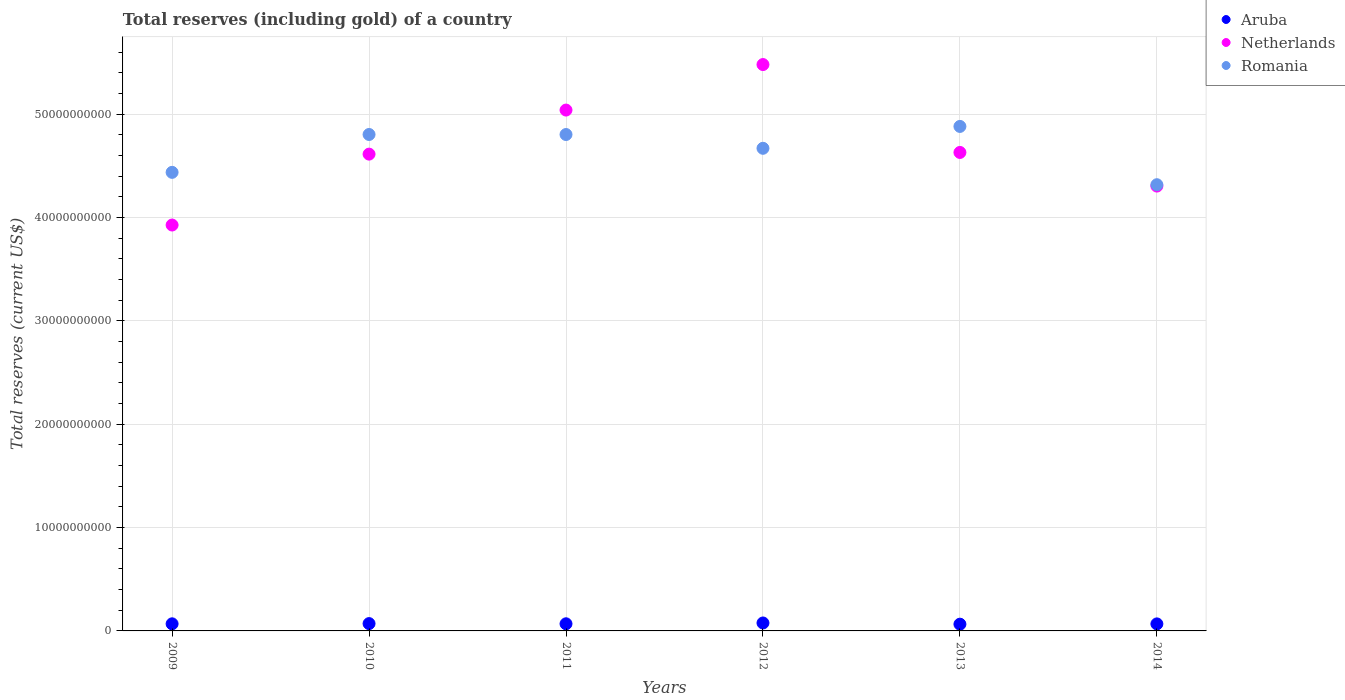How many different coloured dotlines are there?
Offer a terse response. 3. Is the number of dotlines equal to the number of legend labels?
Offer a terse response. Yes. What is the total reserves (including gold) in Aruba in 2013?
Make the answer very short. 6.53e+08. Across all years, what is the maximum total reserves (including gold) in Romania?
Give a very brief answer. 4.88e+1. Across all years, what is the minimum total reserves (including gold) in Netherlands?
Provide a succinct answer. 3.93e+1. What is the total total reserves (including gold) in Aruba in the graph?
Make the answer very short. 4.19e+09. What is the difference between the total reserves (including gold) in Netherlands in 2009 and that in 2013?
Offer a very short reply. -7.02e+09. What is the difference between the total reserves (including gold) in Romania in 2013 and the total reserves (including gold) in Netherlands in 2009?
Ensure brevity in your answer.  9.54e+09. What is the average total reserves (including gold) in Netherlands per year?
Keep it short and to the point. 4.67e+1. In the year 2011, what is the difference between the total reserves (including gold) in Romania and total reserves (including gold) in Netherlands?
Provide a short and direct response. -2.37e+09. What is the ratio of the total reserves (including gold) in Netherlands in 2010 to that in 2013?
Ensure brevity in your answer.  1. Is the difference between the total reserves (including gold) in Romania in 2011 and 2014 greater than the difference between the total reserves (including gold) in Netherlands in 2011 and 2014?
Provide a succinct answer. No. What is the difference between the highest and the second highest total reserves (including gold) in Romania?
Make the answer very short. 7.80e+08. What is the difference between the highest and the lowest total reserves (including gold) in Romania?
Offer a terse response. 5.64e+09. In how many years, is the total reserves (including gold) in Romania greater than the average total reserves (including gold) in Romania taken over all years?
Offer a terse response. 4. How many years are there in the graph?
Your answer should be compact. 6. Are the values on the major ticks of Y-axis written in scientific E-notation?
Your response must be concise. No. How are the legend labels stacked?
Give a very brief answer. Vertical. What is the title of the graph?
Keep it short and to the point. Total reserves (including gold) of a country. What is the label or title of the X-axis?
Ensure brevity in your answer.  Years. What is the label or title of the Y-axis?
Your response must be concise. Total reserves (current US$). What is the Total reserves (current US$) in Aruba in 2009?
Provide a short and direct response. 6.87e+08. What is the Total reserves (current US$) in Netherlands in 2009?
Provide a succinct answer. 3.93e+1. What is the Total reserves (current US$) of Romania in 2009?
Provide a short and direct response. 4.44e+1. What is the Total reserves (current US$) of Aruba in 2010?
Your response must be concise. 7.09e+08. What is the Total reserves (current US$) of Netherlands in 2010?
Provide a short and direct response. 4.61e+1. What is the Total reserves (current US$) of Romania in 2010?
Provide a short and direct response. 4.80e+1. What is the Total reserves (current US$) in Aruba in 2011?
Keep it short and to the point. 6.90e+08. What is the Total reserves (current US$) in Netherlands in 2011?
Offer a very short reply. 5.04e+1. What is the Total reserves (current US$) in Romania in 2011?
Your answer should be compact. 4.80e+1. What is the Total reserves (current US$) in Aruba in 2012?
Provide a succinct answer. 7.69e+08. What is the Total reserves (current US$) in Netherlands in 2012?
Offer a terse response. 5.48e+1. What is the Total reserves (current US$) in Romania in 2012?
Offer a terse response. 4.67e+1. What is the Total reserves (current US$) in Aruba in 2013?
Ensure brevity in your answer.  6.53e+08. What is the Total reserves (current US$) of Netherlands in 2013?
Give a very brief answer. 4.63e+1. What is the Total reserves (current US$) in Romania in 2013?
Your answer should be compact. 4.88e+1. What is the Total reserves (current US$) of Aruba in 2014?
Ensure brevity in your answer.  6.80e+08. What is the Total reserves (current US$) of Netherlands in 2014?
Offer a very short reply. 4.31e+1. What is the Total reserves (current US$) of Romania in 2014?
Provide a succinct answer. 4.32e+1. Across all years, what is the maximum Total reserves (current US$) in Aruba?
Your answer should be very brief. 7.69e+08. Across all years, what is the maximum Total reserves (current US$) in Netherlands?
Your answer should be compact. 5.48e+1. Across all years, what is the maximum Total reserves (current US$) of Romania?
Give a very brief answer. 4.88e+1. Across all years, what is the minimum Total reserves (current US$) in Aruba?
Provide a short and direct response. 6.53e+08. Across all years, what is the minimum Total reserves (current US$) in Netherlands?
Keep it short and to the point. 3.93e+1. Across all years, what is the minimum Total reserves (current US$) in Romania?
Offer a very short reply. 4.32e+1. What is the total Total reserves (current US$) in Aruba in the graph?
Provide a succinct answer. 4.19e+09. What is the total Total reserves (current US$) of Netherlands in the graph?
Provide a succinct answer. 2.80e+11. What is the total Total reserves (current US$) in Romania in the graph?
Make the answer very short. 2.79e+11. What is the difference between the Total reserves (current US$) of Aruba in 2009 and that in 2010?
Provide a succinct answer. -2.17e+07. What is the difference between the Total reserves (current US$) of Netherlands in 2009 and that in 2010?
Your response must be concise. -6.86e+09. What is the difference between the Total reserves (current US$) in Romania in 2009 and that in 2010?
Keep it short and to the point. -3.66e+09. What is the difference between the Total reserves (current US$) in Aruba in 2009 and that in 2011?
Ensure brevity in your answer.  -2.81e+06. What is the difference between the Total reserves (current US$) in Netherlands in 2009 and that in 2011?
Provide a succinct answer. -1.11e+1. What is the difference between the Total reserves (current US$) of Romania in 2009 and that in 2011?
Make the answer very short. -3.66e+09. What is the difference between the Total reserves (current US$) of Aruba in 2009 and that in 2012?
Keep it short and to the point. -8.17e+07. What is the difference between the Total reserves (current US$) of Netherlands in 2009 and that in 2012?
Offer a very short reply. -1.55e+1. What is the difference between the Total reserves (current US$) in Romania in 2009 and that in 2012?
Offer a very short reply. -2.33e+09. What is the difference between the Total reserves (current US$) in Aruba in 2009 and that in 2013?
Provide a succinct answer. 3.38e+07. What is the difference between the Total reserves (current US$) of Netherlands in 2009 and that in 2013?
Your answer should be compact. -7.02e+09. What is the difference between the Total reserves (current US$) in Romania in 2009 and that in 2013?
Your response must be concise. -4.44e+09. What is the difference between the Total reserves (current US$) in Aruba in 2009 and that in 2014?
Make the answer very short. 6.62e+06. What is the difference between the Total reserves (current US$) of Netherlands in 2009 and that in 2014?
Your answer should be compact. -3.77e+09. What is the difference between the Total reserves (current US$) in Romania in 2009 and that in 2014?
Offer a terse response. 1.20e+09. What is the difference between the Total reserves (current US$) in Aruba in 2010 and that in 2011?
Offer a very short reply. 1.89e+07. What is the difference between the Total reserves (current US$) of Netherlands in 2010 and that in 2011?
Keep it short and to the point. -4.26e+09. What is the difference between the Total reserves (current US$) in Romania in 2010 and that in 2011?
Your answer should be very brief. 3.46e+06. What is the difference between the Total reserves (current US$) in Aruba in 2010 and that in 2012?
Ensure brevity in your answer.  -5.99e+07. What is the difference between the Total reserves (current US$) of Netherlands in 2010 and that in 2012?
Provide a short and direct response. -8.67e+09. What is the difference between the Total reserves (current US$) in Romania in 2010 and that in 2012?
Give a very brief answer. 1.34e+09. What is the difference between the Total reserves (current US$) in Aruba in 2010 and that in 2013?
Your answer should be compact. 5.55e+07. What is the difference between the Total reserves (current US$) of Netherlands in 2010 and that in 2013?
Give a very brief answer. -1.62e+08. What is the difference between the Total reserves (current US$) of Romania in 2010 and that in 2013?
Offer a terse response. -7.80e+08. What is the difference between the Total reserves (current US$) of Aruba in 2010 and that in 2014?
Provide a short and direct response. 2.84e+07. What is the difference between the Total reserves (current US$) of Netherlands in 2010 and that in 2014?
Your answer should be very brief. 3.09e+09. What is the difference between the Total reserves (current US$) of Romania in 2010 and that in 2014?
Your answer should be compact. 4.86e+09. What is the difference between the Total reserves (current US$) in Aruba in 2011 and that in 2012?
Provide a short and direct response. -7.88e+07. What is the difference between the Total reserves (current US$) of Netherlands in 2011 and that in 2012?
Keep it short and to the point. -4.41e+09. What is the difference between the Total reserves (current US$) of Romania in 2011 and that in 2012?
Provide a succinct answer. 1.33e+09. What is the difference between the Total reserves (current US$) in Aruba in 2011 and that in 2013?
Provide a short and direct response. 3.66e+07. What is the difference between the Total reserves (current US$) in Netherlands in 2011 and that in 2013?
Offer a very short reply. 4.10e+09. What is the difference between the Total reserves (current US$) of Romania in 2011 and that in 2013?
Offer a terse response. -7.83e+08. What is the difference between the Total reserves (current US$) in Aruba in 2011 and that in 2014?
Your response must be concise. 9.42e+06. What is the difference between the Total reserves (current US$) of Netherlands in 2011 and that in 2014?
Your response must be concise. 7.36e+09. What is the difference between the Total reserves (current US$) of Romania in 2011 and that in 2014?
Provide a succinct answer. 4.86e+09. What is the difference between the Total reserves (current US$) in Aruba in 2012 and that in 2013?
Your response must be concise. 1.15e+08. What is the difference between the Total reserves (current US$) of Netherlands in 2012 and that in 2013?
Keep it short and to the point. 8.51e+09. What is the difference between the Total reserves (current US$) of Romania in 2012 and that in 2013?
Make the answer very short. -2.12e+09. What is the difference between the Total reserves (current US$) of Aruba in 2012 and that in 2014?
Ensure brevity in your answer.  8.83e+07. What is the difference between the Total reserves (current US$) of Netherlands in 2012 and that in 2014?
Your answer should be very brief. 1.18e+1. What is the difference between the Total reserves (current US$) in Romania in 2012 and that in 2014?
Your answer should be compact. 3.52e+09. What is the difference between the Total reserves (current US$) of Aruba in 2013 and that in 2014?
Offer a terse response. -2.72e+07. What is the difference between the Total reserves (current US$) of Netherlands in 2013 and that in 2014?
Offer a terse response. 3.25e+09. What is the difference between the Total reserves (current US$) of Romania in 2013 and that in 2014?
Your answer should be compact. 5.64e+09. What is the difference between the Total reserves (current US$) in Aruba in 2009 and the Total reserves (current US$) in Netherlands in 2010?
Your response must be concise. -4.55e+1. What is the difference between the Total reserves (current US$) of Aruba in 2009 and the Total reserves (current US$) of Romania in 2010?
Your answer should be very brief. -4.74e+1. What is the difference between the Total reserves (current US$) of Netherlands in 2009 and the Total reserves (current US$) of Romania in 2010?
Your response must be concise. -8.76e+09. What is the difference between the Total reserves (current US$) of Aruba in 2009 and the Total reserves (current US$) of Netherlands in 2011?
Offer a terse response. -4.97e+1. What is the difference between the Total reserves (current US$) of Aruba in 2009 and the Total reserves (current US$) of Romania in 2011?
Your answer should be compact. -4.74e+1. What is the difference between the Total reserves (current US$) in Netherlands in 2009 and the Total reserves (current US$) in Romania in 2011?
Your answer should be very brief. -8.76e+09. What is the difference between the Total reserves (current US$) of Aruba in 2009 and the Total reserves (current US$) of Netherlands in 2012?
Provide a short and direct response. -5.41e+1. What is the difference between the Total reserves (current US$) of Aruba in 2009 and the Total reserves (current US$) of Romania in 2012?
Provide a short and direct response. -4.60e+1. What is the difference between the Total reserves (current US$) of Netherlands in 2009 and the Total reserves (current US$) of Romania in 2012?
Make the answer very short. -7.43e+09. What is the difference between the Total reserves (current US$) in Aruba in 2009 and the Total reserves (current US$) in Netherlands in 2013?
Provide a short and direct response. -4.56e+1. What is the difference between the Total reserves (current US$) of Aruba in 2009 and the Total reserves (current US$) of Romania in 2013?
Offer a terse response. -4.81e+1. What is the difference between the Total reserves (current US$) in Netherlands in 2009 and the Total reserves (current US$) in Romania in 2013?
Give a very brief answer. -9.54e+09. What is the difference between the Total reserves (current US$) in Aruba in 2009 and the Total reserves (current US$) in Netherlands in 2014?
Give a very brief answer. -4.24e+1. What is the difference between the Total reserves (current US$) of Aruba in 2009 and the Total reserves (current US$) of Romania in 2014?
Ensure brevity in your answer.  -4.25e+1. What is the difference between the Total reserves (current US$) of Netherlands in 2009 and the Total reserves (current US$) of Romania in 2014?
Provide a short and direct response. -3.90e+09. What is the difference between the Total reserves (current US$) of Aruba in 2010 and the Total reserves (current US$) of Netherlands in 2011?
Provide a short and direct response. -4.97e+1. What is the difference between the Total reserves (current US$) of Aruba in 2010 and the Total reserves (current US$) of Romania in 2011?
Provide a succinct answer. -4.73e+1. What is the difference between the Total reserves (current US$) of Netherlands in 2010 and the Total reserves (current US$) of Romania in 2011?
Offer a very short reply. -1.90e+09. What is the difference between the Total reserves (current US$) of Aruba in 2010 and the Total reserves (current US$) of Netherlands in 2012?
Provide a succinct answer. -5.41e+1. What is the difference between the Total reserves (current US$) in Aruba in 2010 and the Total reserves (current US$) in Romania in 2012?
Offer a terse response. -4.60e+1. What is the difference between the Total reserves (current US$) in Netherlands in 2010 and the Total reserves (current US$) in Romania in 2012?
Provide a succinct answer. -5.64e+08. What is the difference between the Total reserves (current US$) in Aruba in 2010 and the Total reserves (current US$) in Netherlands in 2013?
Your answer should be very brief. -4.56e+1. What is the difference between the Total reserves (current US$) of Aruba in 2010 and the Total reserves (current US$) of Romania in 2013?
Provide a short and direct response. -4.81e+1. What is the difference between the Total reserves (current US$) of Netherlands in 2010 and the Total reserves (current US$) of Romania in 2013?
Your answer should be very brief. -2.68e+09. What is the difference between the Total reserves (current US$) in Aruba in 2010 and the Total reserves (current US$) in Netherlands in 2014?
Your answer should be very brief. -4.23e+1. What is the difference between the Total reserves (current US$) of Aruba in 2010 and the Total reserves (current US$) of Romania in 2014?
Your answer should be compact. -4.25e+1. What is the difference between the Total reserves (current US$) of Netherlands in 2010 and the Total reserves (current US$) of Romania in 2014?
Give a very brief answer. 2.96e+09. What is the difference between the Total reserves (current US$) of Aruba in 2011 and the Total reserves (current US$) of Netherlands in 2012?
Provide a short and direct response. -5.41e+1. What is the difference between the Total reserves (current US$) in Aruba in 2011 and the Total reserves (current US$) in Romania in 2012?
Your answer should be very brief. -4.60e+1. What is the difference between the Total reserves (current US$) in Netherlands in 2011 and the Total reserves (current US$) in Romania in 2012?
Provide a succinct answer. 3.70e+09. What is the difference between the Total reserves (current US$) in Aruba in 2011 and the Total reserves (current US$) in Netherlands in 2013?
Your answer should be compact. -4.56e+1. What is the difference between the Total reserves (current US$) in Aruba in 2011 and the Total reserves (current US$) in Romania in 2013?
Your response must be concise. -4.81e+1. What is the difference between the Total reserves (current US$) of Netherlands in 2011 and the Total reserves (current US$) of Romania in 2013?
Offer a terse response. 1.58e+09. What is the difference between the Total reserves (current US$) of Aruba in 2011 and the Total reserves (current US$) of Netherlands in 2014?
Make the answer very short. -4.24e+1. What is the difference between the Total reserves (current US$) of Aruba in 2011 and the Total reserves (current US$) of Romania in 2014?
Make the answer very short. -4.25e+1. What is the difference between the Total reserves (current US$) of Netherlands in 2011 and the Total reserves (current US$) of Romania in 2014?
Your response must be concise. 7.22e+09. What is the difference between the Total reserves (current US$) of Aruba in 2012 and the Total reserves (current US$) of Netherlands in 2013?
Keep it short and to the point. -4.55e+1. What is the difference between the Total reserves (current US$) of Aruba in 2012 and the Total reserves (current US$) of Romania in 2013?
Keep it short and to the point. -4.81e+1. What is the difference between the Total reserves (current US$) in Netherlands in 2012 and the Total reserves (current US$) in Romania in 2013?
Offer a very short reply. 5.99e+09. What is the difference between the Total reserves (current US$) of Aruba in 2012 and the Total reserves (current US$) of Netherlands in 2014?
Provide a short and direct response. -4.23e+1. What is the difference between the Total reserves (current US$) in Aruba in 2012 and the Total reserves (current US$) in Romania in 2014?
Your response must be concise. -4.24e+1. What is the difference between the Total reserves (current US$) of Netherlands in 2012 and the Total reserves (current US$) of Romania in 2014?
Provide a succinct answer. 1.16e+1. What is the difference between the Total reserves (current US$) in Aruba in 2013 and the Total reserves (current US$) in Netherlands in 2014?
Keep it short and to the point. -4.24e+1. What is the difference between the Total reserves (current US$) in Aruba in 2013 and the Total reserves (current US$) in Romania in 2014?
Your response must be concise. -4.25e+1. What is the difference between the Total reserves (current US$) of Netherlands in 2013 and the Total reserves (current US$) of Romania in 2014?
Provide a succinct answer. 3.12e+09. What is the average Total reserves (current US$) in Aruba per year?
Keep it short and to the point. 6.98e+08. What is the average Total reserves (current US$) in Netherlands per year?
Ensure brevity in your answer.  4.67e+1. What is the average Total reserves (current US$) of Romania per year?
Provide a short and direct response. 4.65e+1. In the year 2009, what is the difference between the Total reserves (current US$) of Aruba and Total reserves (current US$) of Netherlands?
Ensure brevity in your answer.  -3.86e+1. In the year 2009, what is the difference between the Total reserves (current US$) of Aruba and Total reserves (current US$) of Romania?
Your answer should be very brief. -4.37e+1. In the year 2009, what is the difference between the Total reserves (current US$) of Netherlands and Total reserves (current US$) of Romania?
Keep it short and to the point. -5.10e+09. In the year 2010, what is the difference between the Total reserves (current US$) of Aruba and Total reserves (current US$) of Netherlands?
Offer a terse response. -4.54e+1. In the year 2010, what is the difference between the Total reserves (current US$) in Aruba and Total reserves (current US$) in Romania?
Make the answer very short. -4.73e+1. In the year 2010, what is the difference between the Total reserves (current US$) of Netherlands and Total reserves (current US$) of Romania?
Offer a very short reply. -1.90e+09. In the year 2011, what is the difference between the Total reserves (current US$) in Aruba and Total reserves (current US$) in Netherlands?
Offer a terse response. -4.97e+1. In the year 2011, what is the difference between the Total reserves (current US$) in Aruba and Total reserves (current US$) in Romania?
Make the answer very short. -4.74e+1. In the year 2011, what is the difference between the Total reserves (current US$) in Netherlands and Total reserves (current US$) in Romania?
Provide a short and direct response. 2.37e+09. In the year 2012, what is the difference between the Total reserves (current US$) of Aruba and Total reserves (current US$) of Netherlands?
Provide a succinct answer. -5.40e+1. In the year 2012, what is the difference between the Total reserves (current US$) in Aruba and Total reserves (current US$) in Romania?
Your response must be concise. -4.59e+1. In the year 2012, what is the difference between the Total reserves (current US$) of Netherlands and Total reserves (current US$) of Romania?
Offer a very short reply. 8.10e+09. In the year 2013, what is the difference between the Total reserves (current US$) in Aruba and Total reserves (current US$) in Netherlands?
Provide a succinct answer. -4.57e+1. In the year 2013, what is the difference between the Total reserves (current US$) of Aruba and Total reserves (current US$) of Romania?
Keep it short and to the point. -4.82e+1. In the year 2013, what is the difference between the Total reserves (current US$) in Netherlands and Total reserves (current US$) in Romania?
Offer a very short reply. -2.52e+09. In the year 2014, what is the difference between the Total reserves (current US$) in Aruba and Total reserves (current US$) in Netherlands?
Ensure brevity in your answer.  -4.24e+1. In the year 2014, what is the difference between the Total reserves (current US$) in Aruba and Total reserves (current US$) in Romania?
Ensure brevity in your answer.  -4.25e+1. In the year 2014, what is the difference between the Total reserves (current US$) of Netherlands and Total reserves (current US$) of Romania?
Make the answer very short. -1.32e+08. What is the ratio of the Total reserves (current US$) of Aruba in 2009 to that in 2010?
Ensure brevity in your answer.  0.97. What is the ratio of the Total reserves (current US$) in Netherlands in 2009 to that in 2010?
Offer a terse response. 0.85. What is the ratio of the Total reserves (current US$) of Romania in 2009 to that in 2010?
Offer a very short reply. 0.92. What is the ratio of the Total reserves (current US$) of Aruba in 2009 to that in 2011?
Give a very brief answer. 1. What is the ratio of the Total reserves (current US$) in Netherlands in 2009 to that in 2011?
Provide a succinct answer. 0.78. What is the ratio of the Total reserves (current US$) in Romania in 2009 to that in 2011?
Make the answer very short. 0.92. What is the ratio of the Total reserves (current US$) in Aruba in 2009 to that in 2012?
Give a very brief answer. 0.89. What is the ratio of the Total reserves (current US$) in Netherlands in 2009 to that in 2012?
Offer a very short reply. 0.72. What is the ratio of the Total reserves (current US$) of Romania in 2009 to that in 2012?
Ensure brevity in your answer.  0.95. What is the ratio of the Total reserves (current US$) in Aruba in 2009 to that in 2013?
Keep it short and to the point. 1.05. What is the ratio of the Total reserves (current US$) of Netherlands in 2009 to that in 2013?
Keep it short and to the point. 0.85. What is the ratio of the Total reserves (current US$) of Romania in 2009 to that in 2013?
Provide a short and direct response. 0.91. What is the ratio of the Total reserves (current US$) of Aruba in 2009 to that in 2014?
Offer a very short reply. 1.01. What is the ratio of the Total reserves (current US$) in Netherlands in 2009 to that in 2014?
Your response must be concise. 0.91. What is the ratio of the Total reserves (current US$) of Romania in 2009 to that in 2014?
Your answer should be very brief. 1.03. What is the ratio of the Total reserves (current US$) in Aruba in 2010 to that in 2011?
Offer a very short reply. 1.03. What is the ratio of the Total reserves (current US$) of Netherlands in 2010 to that in 2011?
Your answer should be compact. 0.92. What is the ratio of the Total reserves (current US$) in Romania in 2010 to that in 2011?
Your answer should be very brief. 1. What is the ratio of the Total reserves (current US$) in Aruba in 2010 to that in 2012?
Your response must be concise. 0.92. What is the ratio of the Total reserves (current US$) in Netherlands in 2010 to that in 2012?
Provide a succinct answer. 0.84. What is the ratio of the Total reserves (current US$) in Romania in 2010 to that in 2012?
Ensure brevity in your answer.  1.03. What is the ratio of the Total reserves (current US$) of Aruba in 2010 to that in 2013?
Ensure brevity in your answer.  1.08. What is the ratio of the Total reserves (current US$) of Aruba in 2010 to that in 2014?
Provide a succinct answer. 1.04. What is the ratio of the Total reserves (current US$) of Netherlands in 2010 to that in 2014?
Keep it short and to the point. 1.07. What is the ratio of the Total reserves (current US$) in Romania in 2010 to that in 2014?
Provide a short and direct response. 1.11. What is the ratio of the Total reserves (current US$) of Aruba in 2011 to that in 2012?
Provide a short and direct response. 0.9. What is the ratio of the Total reserves (current US$) of Netherlands in 2011 to that in 2012?
Offer a terse response. 0.92. What is the ratio of the Total reserves (current US$) in Romania in 2011 to that in 2012?
Your answer should be very brief. 1.03. What is the ratio of the Total reserves (current US$) in Aruba in 2011 to that in 2013?
Keep it short and to the point. 1.06. What is the ratio of the Total reserves (current US$) in Netherlands in 2011 to that in 2013?
Make the answer very short. 1.09. What is the ratio of the Total reserves (current US$) of Aruba in 2011 to that in 2014?
Provide a short and direct response. 1.01. What is the ratio of the Total reserves (current US$) of Netherlands in 2011 to that in 2014?
Your answer should be compact. 1.17. What is the ratio of the Total reserves (current US$) in Romania in 2011 to that in 2014?
Your answer should be compact. 1.11. What is the ratio of the Total reserves (current US$) of Aruba in 2012 to that in 2013?
Offer a very short reply. 1.18. What is the ratio of the Total reserves (current US$) of Netherlands in 2012 to that in 2013?
Provide a succinct answer. 1.18. What is the ratio of the Total reserves (current US$) in Romania in 2012 to that in 2013?
Your answer should be compact. 0.96. What is the ratio of the Total reserves (current US$) of Aruba in 2012 to that in 2014?
Ensure brevity in your answer.  1.13. What is the ratio of the Total reserves (current US$) of Netherlands in 2012 to that in 2014?
Make the answer very short. 1.27. What is the ratio of the Total reserves (current US$) in Romania in 2012 to that in 2014?
Make the answer very short. 1.08. What is the ratio of the Total reserves (current US$) of Netherlands in 2013 to that in 2014?
Make the answer very short. 1.08. What is the ratio of the Total reserves (current US$) of Romania in 2013 to that in 2014?
Your answer should be very brief. 1.13. What is the difference between the highest and the second highest Total reserves (current US$) in Aruba?
Your answer should be very brief. 5.99e+07. What is the difference between the highest and the second highest Total reserves (current US$) in Netherlands?
Your response must be concise. 4.41e+09. What is the difference between the highest and the second highest Total reserves (current US$) in Romania?
Provide a succinct answer. 7.80e+08. What is the difference between the highest and the lowest Total reserves (current US$) of Aruba?
Your answer should be very brief. 1.15e+08. What is the difference between the highest and the lowest Total reserves (current US$) in Netherlands?
Offer a very short reply. 1.55e+1. What is the difference between the highest and the lowest Total reserves (current US$) in Romania?
Your answer should be compact. 5.64e+09. 